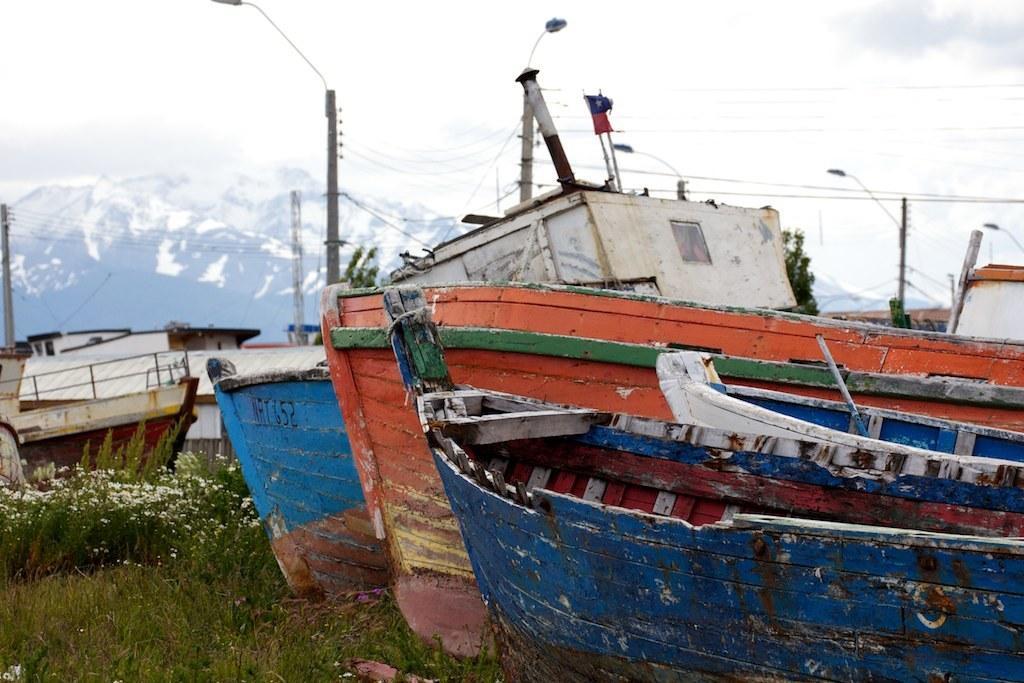Please provide a concise description of this image. In this image we can see boats on the land. On the ground there is grass with flowers. And there are buildings and electric poles with wires and lights. In the back there is mountain. Also there is sky with clouds. 